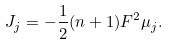<formula> <loc_0><loc_0><loc_500><loc_500>J _ { j } = - \frac { 1 } { 2 } ( n + 1 ) F ^ { 2 } \mu _ { j } .</formula> 